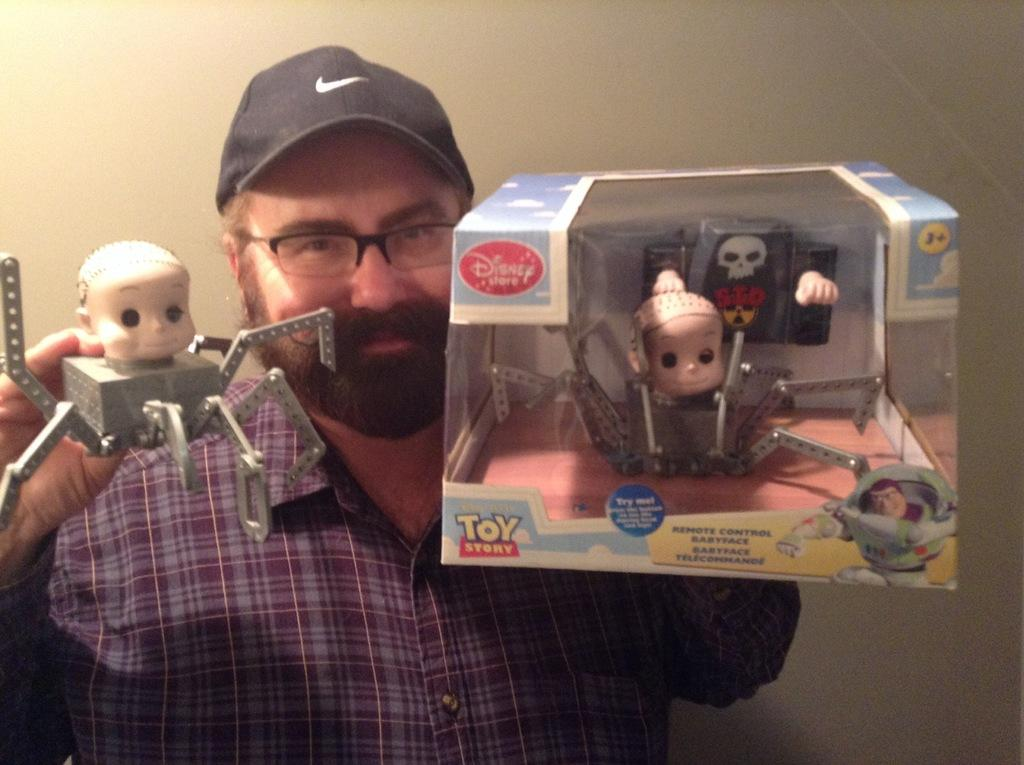Who is present in the image? There is a man in the image. Where is the man located in the image? The man is standing in the middle of the image. What is the man doing in the image? The man is smiling and holding toys. What is visible behind the man in the image? There is a wall behind the man. What type of grain can be seen growing in the middle of the image? There is no grain present in the image; it features a man standing in the middle of the image. What kind of music is being played in the background of the image? There is no music present in the image; it only shows a man standing and holding toys. 